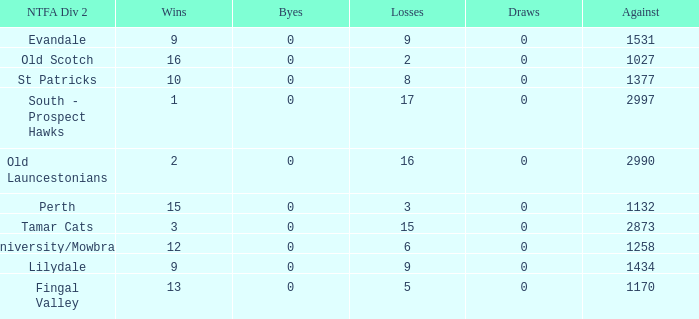What is the lowest number of against of NTFA Div 2 Fingal Valley? 1170.0. 